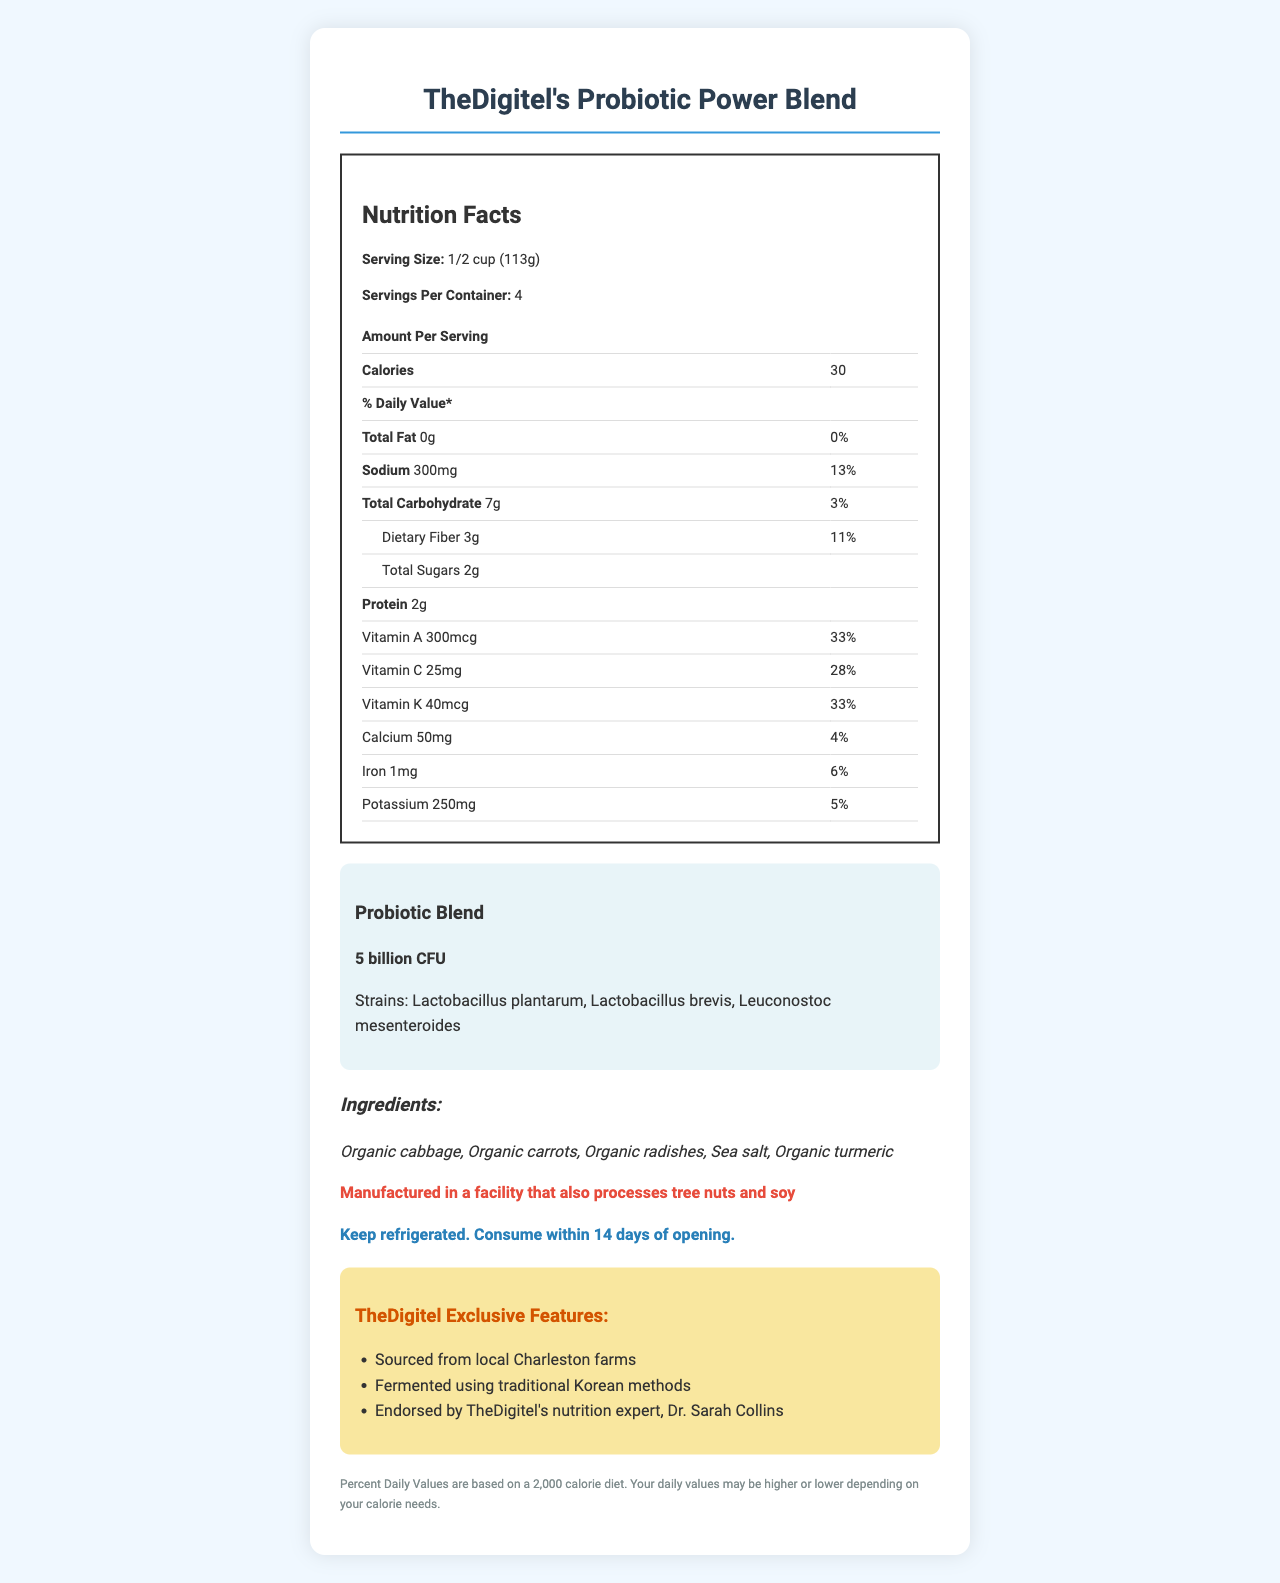what is the serving size? The serving size is stated as "1/2 cup (113g)" at the beginning of the document.
Answer: 1/2 cup (113g) how many calories are in one serving? The document lists the calories per serving as 30.
Answer: 30 what is the amount of dietary fiber per serving? The document provides that there are 3g of dietary fiber per serving.
Answer: 3g what is the percentage daily value of sodium? The percentage daily value for sodium is listed as 13%.
Answer: 13% how much vitamin A is in one serving? The document states that each serving contains 300mcg of vitamin A.
Answer: 300mcg what is the live culture count of the probiotic blend? The probiotic blend contains 5 billion CFU.
Answer: 5 billion CFU what are the three strains in the probiotic blend? These strains are listed in the probiotic blend section of the document.
Answer: Lactobacillus plantarum, Lactobacillus brevis, Leuconostoc mesenteroides how much protein is in one serving? The document states that there are 2g of protein per serving.
Answer: 2g which vitamin has the highest percentage daily value? A. Vitamin A B. Vitamin C C. Vitamin K D. Calcium Vitamin A has a daily value of 33%, which is the highest among the listed vitamins and minerals.
Answer: A which of the following is NOT an ingredient in TheDigitel's Probiotic Power Blend? A. Organic cabbage B. Organic carrots C. Organic potatoes D. Sea salt The ingredients list does not include organic potatoes.
Answer: C is this product manufactured in a facility that processes tree nuts? The allergen information section states that the product is manufactured in a facility that processes tree nuts and soy.
Answer: Yes describe the main idea of the document The document details the nutritional content, ingredients, and special features of TheDigitel's Probiotic Power Blend, emphasizing its local sourcing and health benefits.
Answer: The document provides detailed Nutrition Facts for TheDigitel's Probiotic Power Blend, a probiotic-rich fermented vegetable blend. It includes serving size, servings per container, caloric content, amounts of various nutrients and vitamins, and probiotic strains. Additional information includes ingredients, allergen info, storage instructions, and exclusive features related to TheDigitel.com. what is the facility's manufacturing process for the probiotic blend? The document mentions the product is manufactured in a facility that processes tree nuts and soy but does not detail the manufacturing process.
Answer: Not enough information 